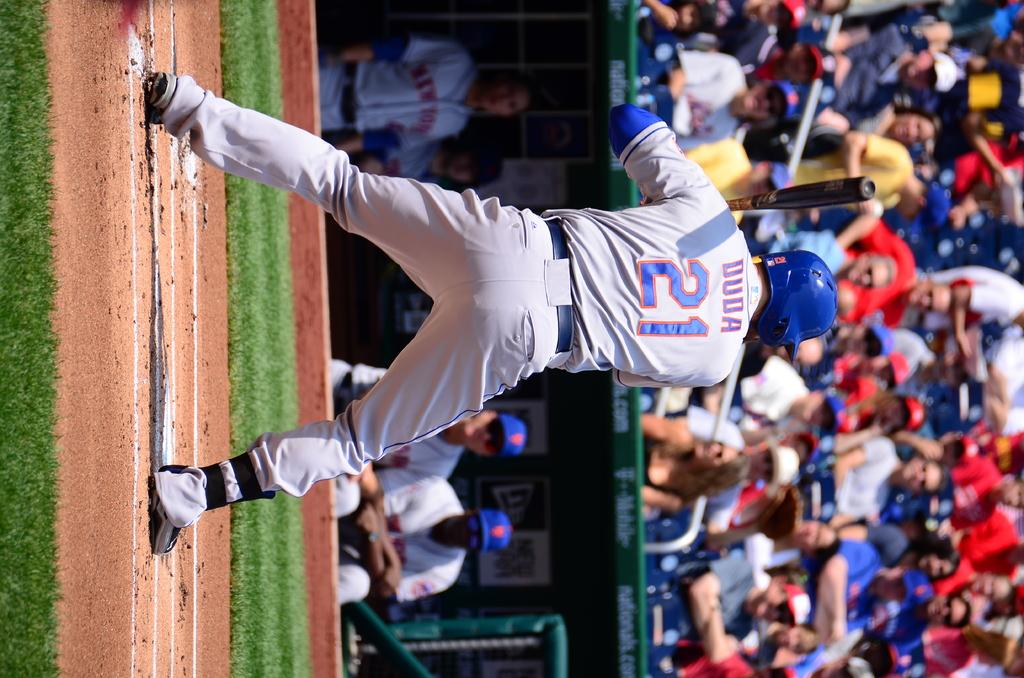Provide a one-sentence caption for the provided image. a baseball player playing on the field jersey reads duda. 